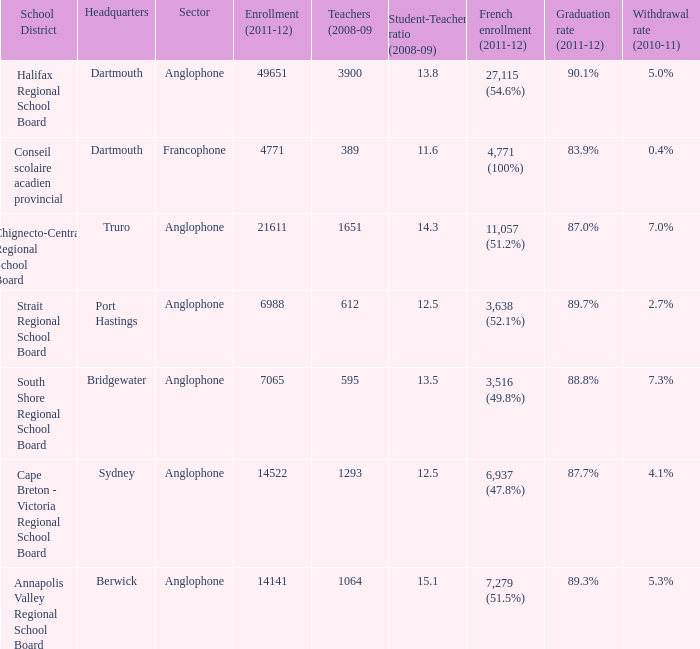What is their withdrawal rate for the school district with headquarters located in Truro? 7.0%. 